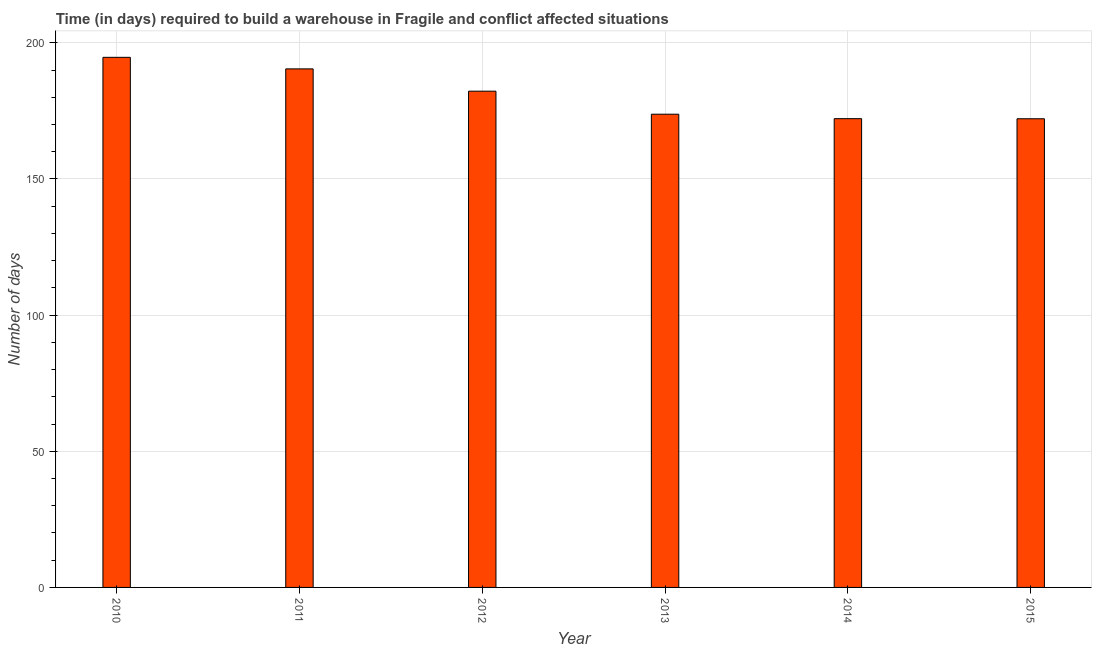Does the graph contain grids?
Provide a succinct answer. Yes. What is the title of the graph?
Provide a short and direct response. Time (in days) required to build a warehouse in Fragile and conflict affected situations. What is the label or title of the Y-axis?
Make the answer very short. Number of days. What is the time required to build a warehouse in 2013?
Your response must be concise. 173.77. Across all years, what is the maximum time required to build a warehouse?
Offer a terse response. 194.66. Across all years, what is the minimum time required to build a warehouse?
Make the answer very short. 172.1. In which year was the time required to build a warehouse maximum?
Provide a short and direct response. 2010. In which year was the time required to build a warehouse minimum?
Your answer should be very brief. 2015. What is the sum of the time required to build a warehouse?
Your response must be concise. 1085.29. What is the difference between the time required to build a warehouse in 2011 and 2015?
Your answer should be very brief. 18.31. What is the average time required to build a warehouse per year?
Offer a very short reply. 180.88. What is the median time required to build a warehouse?
Provide a short and direct response. 178. What is the ratio of the time required to build a warehouse in 2010 to that in 2015?
Your response must be concise. 1.13. What is the difference between the highest and the second highest time required to build a warehouse?
Provide a succinct answer. 4.24. Is the sum of the time required to build a warehouse in 2010 and 2015 greater than the maximum time required to build a warehouse across all years?
Provide a succinct answer. Yes. What is the difference between the highest and the lowest time required to build a warehouse?
Make the answer very short. 22.56. In how many years, is the time required to build a warehouse greater than the average time required to build a warehouse taken over all years?
Provide a short and direct response. 3. Are the values on the major ticks of Y-axis written in scientific E-notation?
Offer a terse response. No. What is the Number of days of 2010?
Provide a short and direct response. 194.66. What is the Number of days in 2011?
Make the answer very short. 190.41. What is the Number of days of 2012?
Provide a short and direct response. 182.23. What is the Number of days of 2013?
Provide a succinct answer. 173.77. What is the Number of days in 2014?
Offer a terse response. 172.13. What is the Number of days of 2015?
Ensure brevity in your answer.  172.1. What is the difference between the Number of days in 2010 and 2011?
Provide a short and direct response. 4.24. What is the difference between the Number of days in 2010 and 2012?
Offer a terse response. 12.43. What is the difference between the Number of days in 2010 and 2013?
Your answer should be compact. 20.89. What is the difference between the Number of days in 2010 and 2014?
Provide a short and direct response. 22.52. What is the difference between the Number of days in 2010 and 2015?
Offer a terse response. 22.56. What is the difference between the Number of days in 2011 and 2012?
Your answer should be compact. 8.19. What is the difference between the Number of days in 2011 and 2013?
Your response must be concise. 16.65. What is the difference between the Number of days in 2011 and 2014?
Your response must be concise. 18.28. What is the difference between the Number of days in 2011 and 2015?
Provide a short and direct response. 18.31. What is the difference between the Number of days in 2012 and 2013?
Offer a very short reply. 8.46. What is the difference between the Number of days in 2012 and 2014?
Your response must be concise. 10.09. What is the difference between the Number of days in 2012 and 2015?
Your answer should be compact. 10.13. What is the difference between the Number of days in 2013 and 2014?
Your answer should be compact. 1.63. What is the difference between the Number of days in 2013 and 2015?
Offer a very short reply. 1.67. What is the difference between the Number of days in 2014 and 2015?
Keep it short and to the point. 0.03. What is the ratio of the Number of days in 2010 to that in 2011?
Offer a terse response. 1.02. What is the ratio of the Number of days in 2010 to that in 2012?
Your answer should be compact. 1.07. What is the ratio of the Number of days in 2010 to that in 2013?
Offer a very short reply. 1.12. What is the ratio of the Number of days in 2010 to that in 2014?
Make the answer very short. 1.13. What is the ratio of the Number of days in 2010 to that in 2015?
Keep it short and to the point. 1.13. What is the ratio of the Number of days in 2011 to that in 2012?
Make the answer very short. 1.04. What is the ratio of the Number of days in 2011 to that in 2013?
Provide a succinct answer. 1.1. What is the ratio of the Number of days in 2011 to that in 2014?
Make the answer very short. 1.11. What is the ratio of the Number of days in 2011 to that in 2015?
Provide a succinct answer. 1.11. What is the ratio of the Number of days in 2012 to that in 2013?
Your answer should be compact. 1.05. What is the ratio of the Number of days in 2012 to that in 2014?
Provide a succinct answer. 1.06. What is the ratio of the Number of days in 2012 to that in 2015?
Provide a short and direct response. 1.06. What is the ratio of the Number of days in 2013 to that in 2015?
Provide a short and direct response. 1.01. 